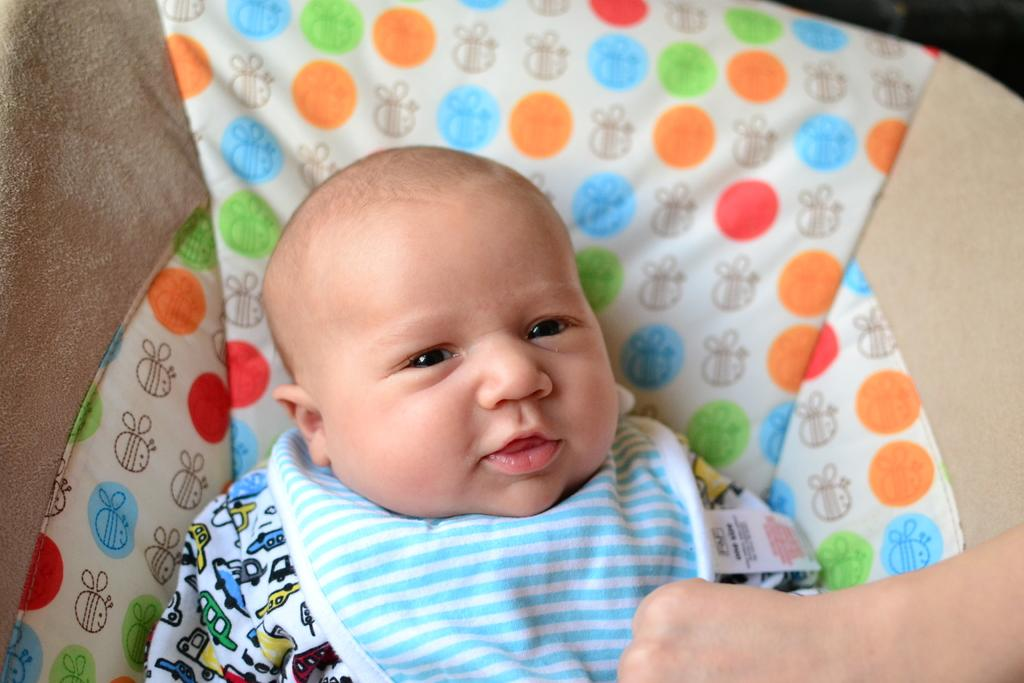What is the main subject of the image? There is a baby in a baby trolley in the image. Can you describe any other elements in the image? The hand of a person is visible at the bottom of the image, and there is a cloth in the background with white, red, orange, and green colors. What type of paste is being applied to the baby's mouth in the image? There is no paste or mouth visible in the image; it only shows a baby in a baby trolley and a hand at the bottom. 